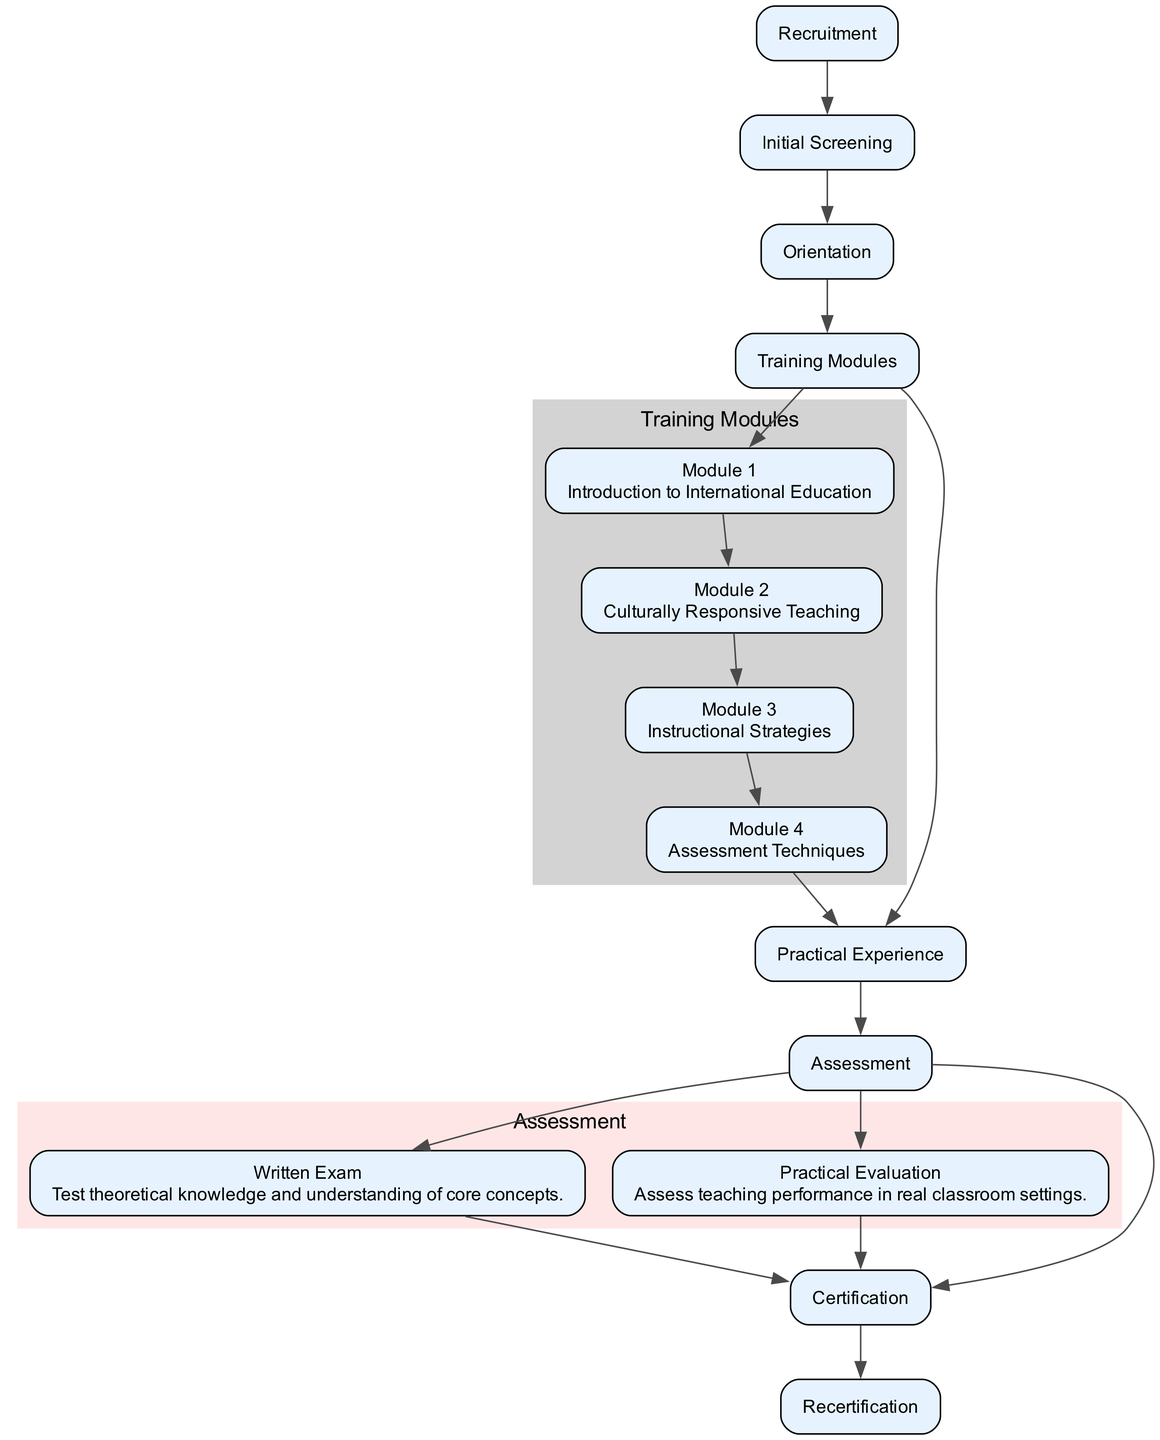What is the first step in the pathway? The pathway starts with the "Recruitment" step, which is defined as identifying potential candidates through job postings and outreach programs.
Answer: Recruitment How many training modules are included in the pathway? There are four training modules listed in the pathway: Introduction to International Education, Culturally Responsive Teaching, Instructional Strategies, and Assessment Techniques.
Answer: Four What type of assessment is conducted to test theoretical knowledge? The assessment type conducted to test theoretical knowledge is the "Written Exam," which tests the theoretical knowledge and understanding of core concepts.
Answer: Written Exam What is the frequency of recertification required for teachers? Recertification is required every five years as stated in the pathway.
Answer: Five years Which step follows the "Practical Experience"? After "Practical Experience," the next step is "Assessment," which includes written and practical evaluations to gauge the trainee's competencies.
Answer: Assessment What is the last step in the teacher training pathway? The last step in the pathway is "Recertification," indicating that teachers must maintain their certification through ongoing professional development every five years.
Answer: Recertification How many assessment types are mentioned in the diagram? There are two assessment types mentioned: Written Exam and Practical Evaluation.
Answer: Two What module focuses on evaluating student progress and performance? The module that focuses on evaluating student progress and performance is "Assessment Techniques."
Answer: Assessment Techniques How does practical experience fit into the teacher training pathway? Practical Experience fits directly after the Training Modules and involves classroom teaching practice with supervised feedback before the Assessment step.
Answer: After Training Modules 